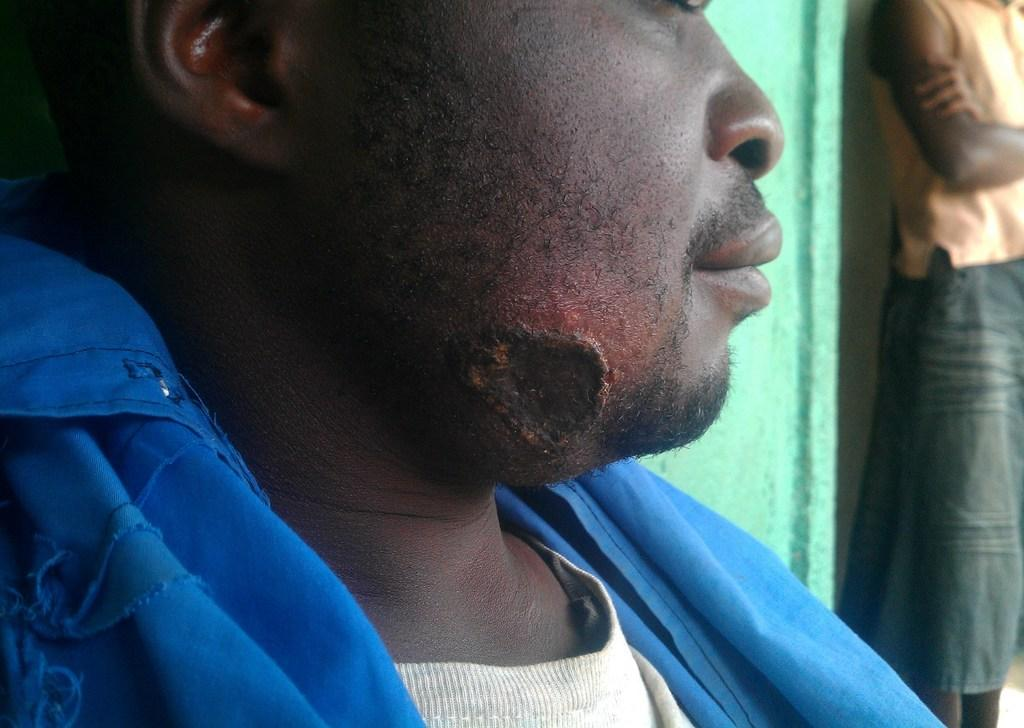What is the position of the person in the image? There is a person sitting in the image. Can you describe any distinguishing features of the sitting person? The sitting person has a scar on their chin. What is the other person in the image doing? There is another person standing in the image. What type of planes can be seen on the sofa in the image? There are no planes or sofas present in the image. 